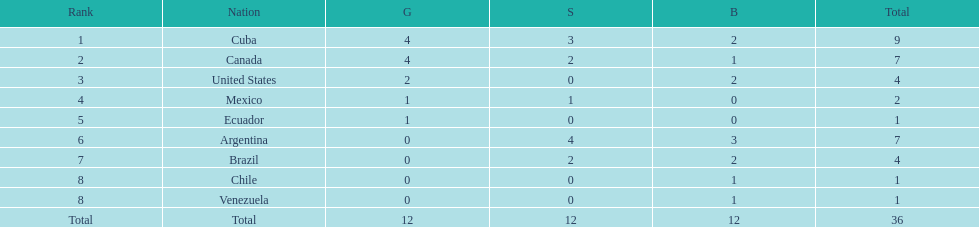How many total medals were there all together? 36. 